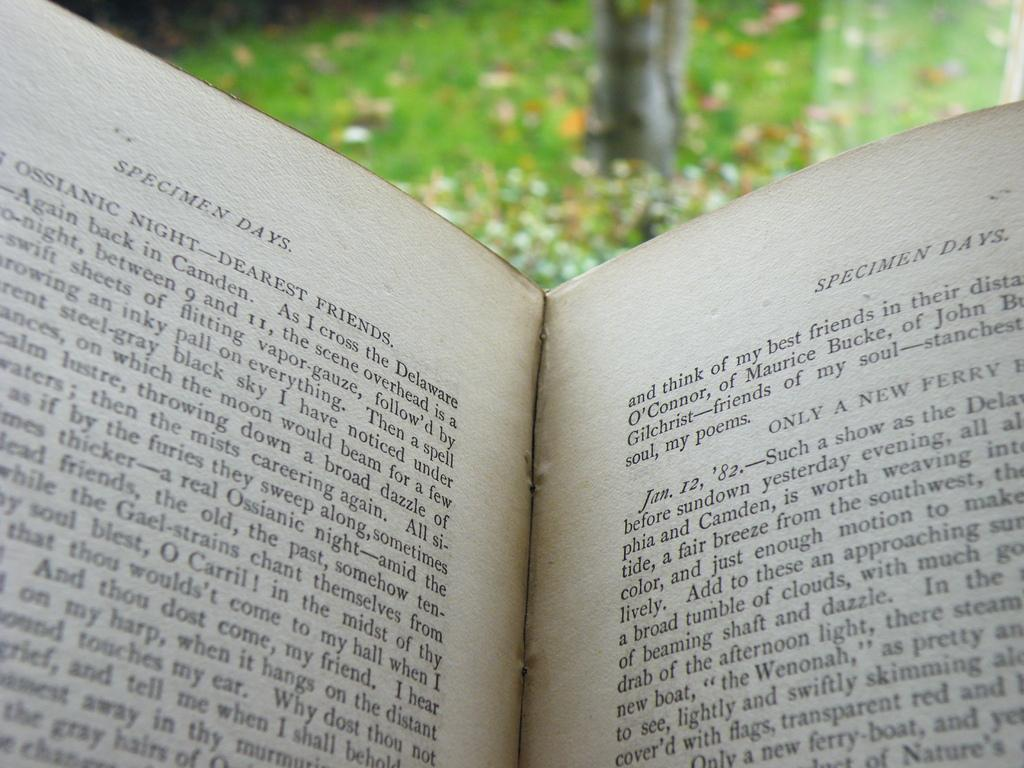Provide a one-sentence caption for the provided image. a open book with the words Specimen Days at the top of it. 